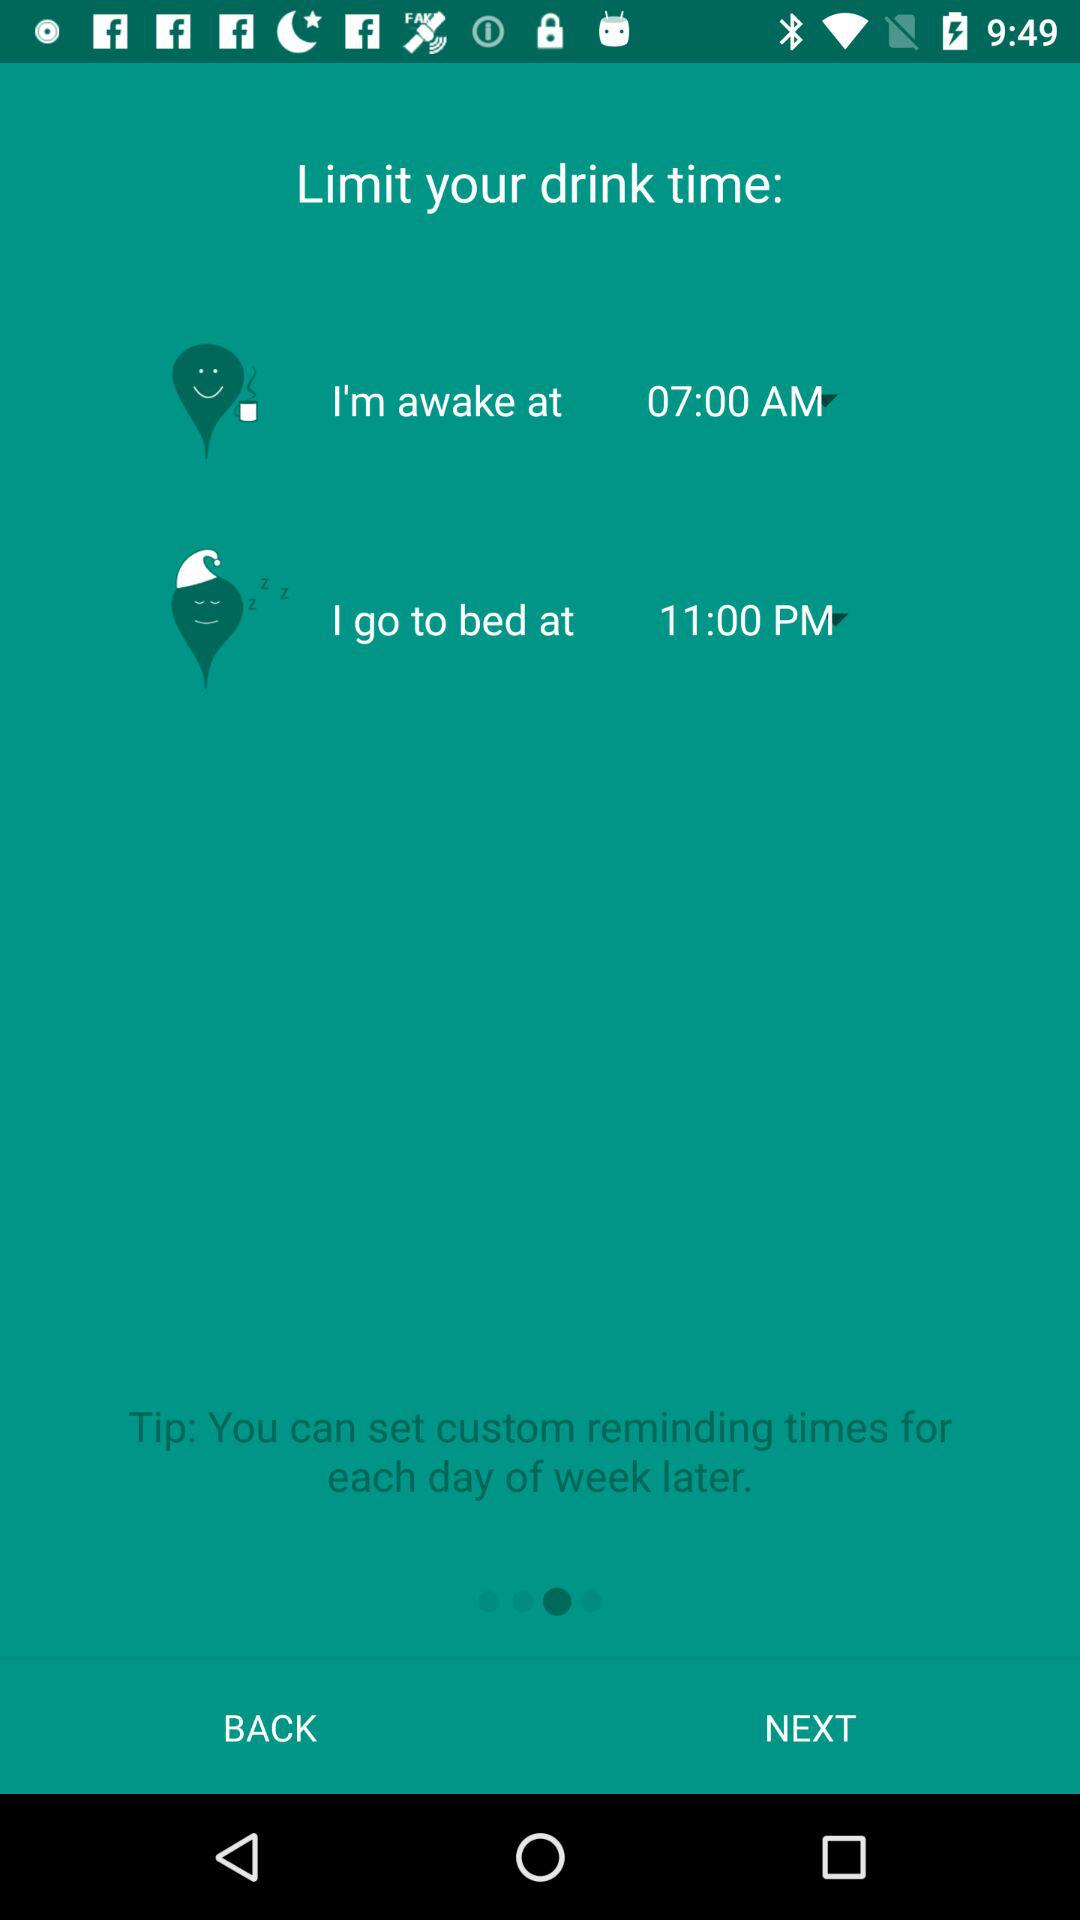How many time intervals are there?
Answer the question using a single word or phrase. 2 